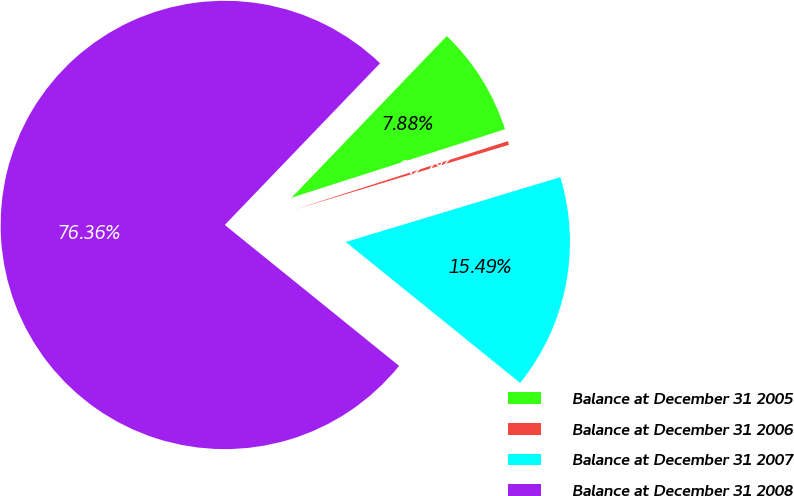<chart> <loc_0><loc_0><loc_500><loc_500><pie_chart><fcel>Balance at December 31 2005<fcel>Balance at December 31 2006<fcel>Balance at December 31 2007<fcel>Balance at December 31 2008<nl><fcel>7.88%<fcel>0.27%<fcel>15.49%<fcel>76.35%<nl></chart> 